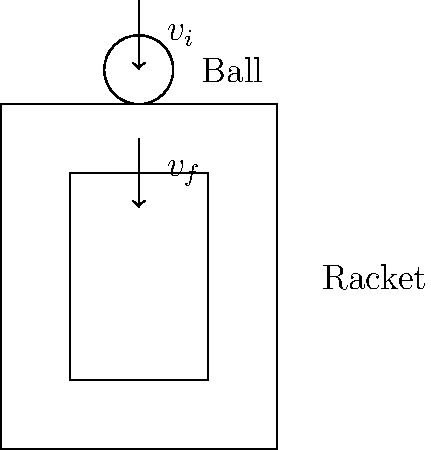A tennis ball with a mass of 58 grams approaches a stationary racket at 30 m/s and rebounds at 25 m/s in the opposite direction. If the contact time between the ball and the racket is 5 milliseconds, what is the average force exerted by the racket on the ball? Let's solve this step-by-step:

1) First, we need to calculate the change in momentum of the tennis ball.

   Initial velocity, $v_i = 30$ m/s (towards the racket)
   Final velocity, $v_f = -25$ m/s (away from the racket)
   Mass of the ball, $m = 58$ g = 0.058 kg

   Change in momentum, $\Delta p = m(v_f - v_i)$
   $\Delta p = 0.058 \times (-25 - 30) = -3.19$ kg⋅m/s

2) The negative sign indicates that the momentum change is in the opposite direction to the initial velocity.

3) Now, we can use the impulse-momentum theorem. The impulse (force × time) equals the change in momentum:

   $F \times \Delta t = \Delta p$

4) We know the contact time, $\Delta t = 5$ ms = 0.005 s

5) Rearranging the equation to solve for force:

   $F = \frac{\Delta p}{\Delta t} = \frac{-3.19}{0.005} = -638$ N

6) The negative sign indicates that the force is in the opposite direction to the initial velocity, which makes sense as it's the force exerted by the racket to reverse the ball's direction.

Therefore, the average force exerted by the racket on the ball is 638 N in the opposite direction to the ball's initial velocity.
Answer: 638 N 